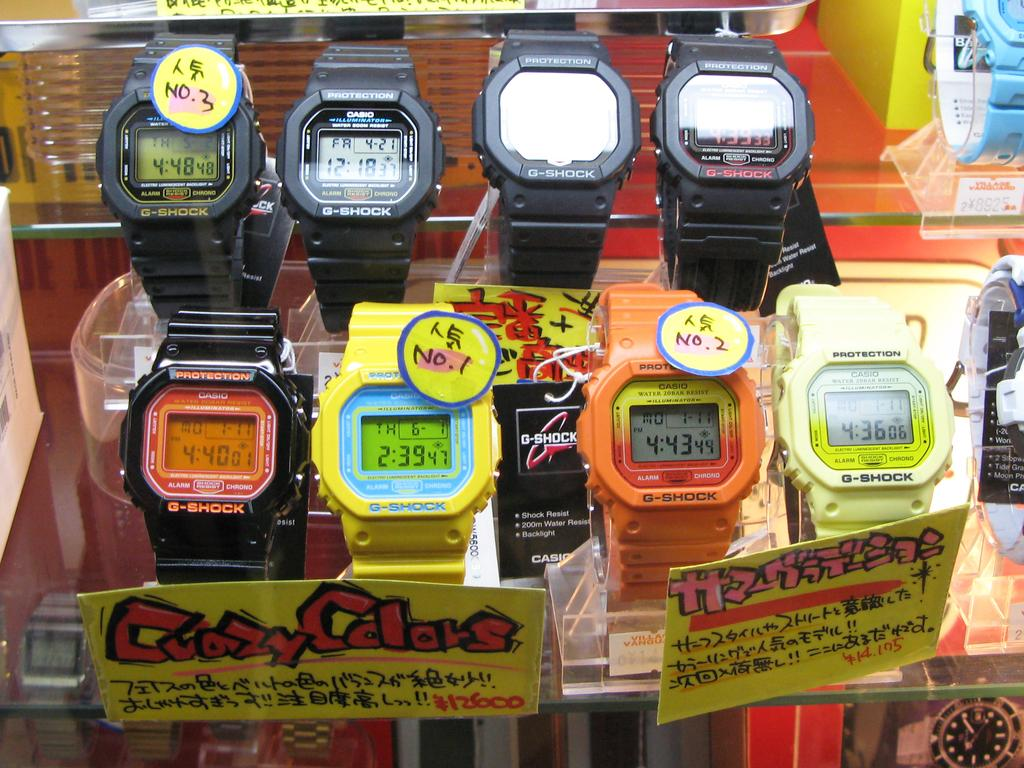<image>
Write a terse but informative summary of the picture. A collection of watches are advertised as having crazy colors. 